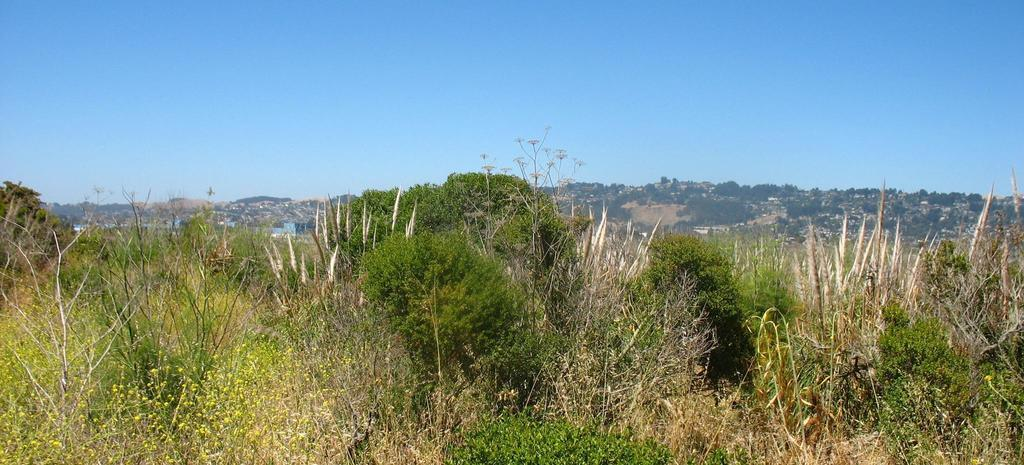What type of vegetation covers the entire place in the image? The entire place in the image is covered with grass. What color is the sky in the image? The sky in the image is blue. How many potatoes can be seen in the image? There are no potatoes present in the image. Can you compare the number of sheep in the image to the number of trees? There are no sheep or trees present in the image, so a comparison cannot be made. 